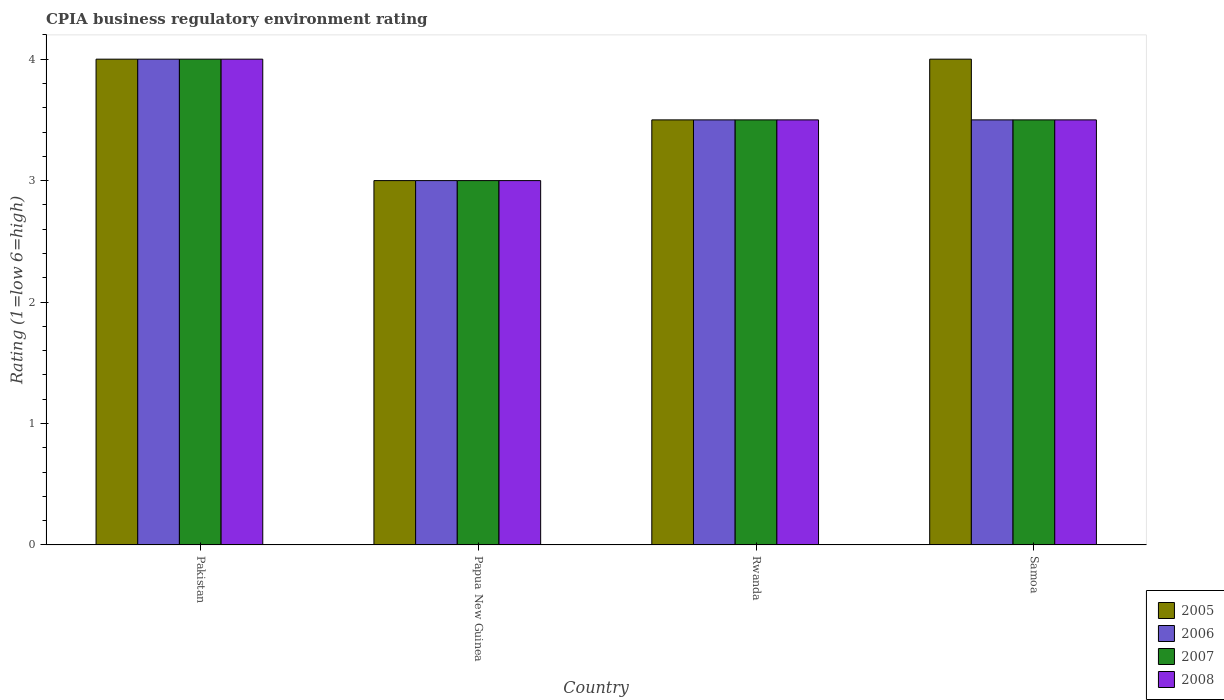Are the number of bars per tick equal to the number of legend labels?
Offer a terse response. Yes. How many bars are there on the 1st tick from the left?
Your answer should be very brief. 4. What is the label of the 4th group of bars from the left?
Provide a short and direct response. Samoa. What is the CPIA rating in 2005 in Papua New Guinea?
Provide a short and direct response. 3. In which country was the CPIA rating in 2007 maximum?
Offer a terse response. Pakistan. In which country was the CPIA rating in 2006 minimum?
Your response must be concise. Papua New Guinea. What is the difference between the CPIA rating in 2008 in Rwanda and the CPIA rating in 2007 in Papua New Guinea?
Your response must be concise. 0.5. In how many countries, is the CPIA rating in 2008 greater than 3?
Ensure brevity in your answer.  3. What is the ratio of the CPIA rating in 2006 in Pakistan to that in Samoa?
Your answer should be compact. 1.14. Is the CPIA rating in 2008 in Papua New Guinea less than that in Samoa?
Ensure brevity in your answer.  Yes. Is the difference between the CPIA rating in 2008 in Papua New Guinea and Samoa greater than the difference between the CPIA rating in 2005 in Papua New Guinea and Samoa?
Make the answer very short. Yes. What is the difference between the highest and the second highest CPIA rating in 2005?
Give a very brief answer. -0.5. Is it the case that in every country, the sum of the CPIA rating in 2006 and CPIA rating in 2007 is greater than the sum of CPIA rating in 2005 and CPIA rating in 2008?
Offer a very short reply. No. What does the 1st bar from the left in Rwanda represents?
Your answer should be compact. 2005. How many bars are there?
Ensure brevity in your answer.  16. Are all the bars in the graph horizontal?
Ensure brevity in your answer.  No. How many countries are there in the graph?
Offer a very short reply. 4. Are the values on the major ticks of Y-axis written in scientific E-notation?
Keep it short and to the point. No. Does the graph contain any zero values?
Provide a succinct answer. No. Does the graph contain grids?
Ensure brevity in your answer.  No. Where does the legend appear in the graph?
Provide a succinct answer. Bottom right. How are the legend labels stacked?
Offer a very short reply. Vertical. What is the title of the graph?
Ensure brevity in your answer.  CPIA business regulatory environment rating. What is the label or title of the X-axis?
Make the answer very short. Country. What is the label or title of the Y-axis?
Ensure brevity in your answer.  Rating (1=low 6=high). What is the Rating (1=low 6=high) in 2008 in Pakistan?
Offer a terse response. 4. What is the Rating (1=low 6=high) of 2006 in Papua New Guinea?
Make the answer very short. 3. What is the Rating (1=low 6=high) of 2005 in Rwanda?
Your response must be concise. 3.5. What is the Rating (1=low 6=high) of 2006 in Rwanda?
Your answer should be very brief. 3.5. What is the Rating (1=low 6=high) of 2007 in Rwanda?
Make the answer very short. 3.5. What is the Rating (1=low 6=high) of 2006 in Samoa?
Your response must be concise. 3.5. What is the Rating (1=low 6=high) in 2008 in Samoa?
Offer a terse response. 3.5. Across all countries, what is the maximum Rating (1=low 6=high) in 2005?
Ensure brevity in your answer.  4. Across all countries, what is the maximum Rating (1=low 6=high) of 2007?
Provide a succinct answer. 4. Across all countries, what is the minimum Rating (1=low 6=high) of 2005?
Give a very brief answer. 3. Across all countries, what is the minimum Rating (1=low 6=high) in 2006?
Provide a short and direct response. 3. What is the total Rating (1=low 6=high) in 2006 in the graph?
Offer a very short reply. 14. What is the difference between the Rating (1=low 6=high) of 2008 in Pakistan and that in Papua New Guinea?
Keep it short and to the point. 1. What is the difference between the Rating (1=low 6=high) of 2005 in Pakistan and that in Rwanda?
Offer a terse response. 0.5. What is the difference between the Rating (1=low 6=high) of 2006 in Pakistan and that in Rwanda?
Keep it short and to the point. 0.5. What is the difference between the Rating (1=low 6=high) of 2005 in Pakistan and that in Samoa?
Your response must be concise. 0. What is the difference between the Rating (1=low 6=high) of 2006 in Pakistan and that in Samoa?
Make the answer very short. 0.5. What is the difference between the Rating (1=low 6=high) of 2007 in Pakistan and that in Samoa?
Give a very brief answer. 0.5. What is the difference between the Rating (1=low 6=high) in 2008 in Papua New Guinea and that in Rwanda?
Offer a very short reply. -0.5. What is the difference between the Rating (1=low 6=high) in 2005 in Papua New Guinea and that in Samoa?
Give a very brief answer. -1. What is the difference between the Rating (1=low 6=high) in 2006 in Papua New Guinea and that in Samoa?
Give a very brief answer. -0.5. What is the difference between the Rating (1=low 6=high) in 2008 in Papua New Guinea and that in Samoa?
Keep it short and to the point. -0.5. What is the difference between the Rating (1=low 6=high) of 2005 in Rwanda and that in Samoa?
Your response must be concise. -0.5. What is the difference between the Rating (1=low 6=high) in 2007 in Rwanda and that in Samoa?
Offer a very short reply. 0. What is the difference between the Rating (1=low 6=high) in 2005 in Pakistan and the Rating (1=low 6=high) in 2006 in Papua New Guinea?
Make the answer very short. 1. What is the difference between the Rating (1=low 6=high) in 2006 in Pakistan and the Rating (1=low 6=high) in 2008 in Papua New Guinea?
Make the answer very short. 1. What is the difference between the Rating (1=low 6=high) in 2005 in Pakistan and the Rating (1=low 6=high) in 2007 in Rwanda?
Make the answer very short. 0.5. What is the difference between the Rating (1=low 6=high) of 2006 in Pakistan and the Rating (1=low 6=high) of 2007 in Rwanda?
Provide a succinct answer. 0.5. What is the difference between the Rating (1=low 6=high) in 2006 in Pakistan and the Rating (1=low 6=high) in 2008 in Rwanda?
Provide a short and direct response. 0.5. What is the difference between the Rating (1=low 6=high) of 2007 in Pakistan and the Rating (1=low 6=high) of 2008 in Rwanda?
Keep it short and to the point. 0.5. What is the difference between the Rating (1=low 6=high) in 2005 in Pakistan and the Rating (1=low 6=high) in 2006 in Samoa?
Provide a short and direct response. 0.5. What is the difference between the Rating (1=low 6=high) of 2007 in Pakistan and the Rating (1=low 6=high) of 2008 in Samoa?
Make the answer very short. 0.5. What is the difference between the Rating (1=low 6=high) of 2005 in Papua New Guinea and the Rating (1=low 6=high) of 2006 in Rwanda?
Your response must be concise. -0.5. What is the difference between the Rating (1=low 6=high) in 2005 in Papua New Guinea and the Rating (1=low 6=high) in 2007 in Rwanda?
Your answer should be very brief. -0.5. What is the difference between the Rating (1=low 6=high) of 2005 in Papua New Guinea and the Rating (1=low 6=high) of 2008 in Rwanda?
Provide a succinct answer. -0.5. What is the difference between the Rating (1=low 6=high) of 2006 in Papua New Guinea and the Rating (1=low 6=high) of 2007 in Rwanda?
Provide a short and direct response. -0.5. What is the difference between the Rating (1=low 6=high) in 2005 in Papua New Guinea and the Rating (1=low 6=high) in 2006 in Samoa?
Offer a terse response. -0.5. What is the difference between the Rating (1=low 6=high) of 2005 in Papua New Guinea and the Rating (1=low 6=high) of 2007 in Samoa?
Give a very brief answer. -0.5. What is the difference between the Rating (1=low 6=high) of 2006 in Papua New Guinea and the Rating (1=low 6=high) of 2007 in Samoa?
Your answer should be very brief. -0.5. What is the difference between the Rating (1=low 6=high) in 2006 in Papua New Guinea and the Rating (1=low 6=high) in 2008 in Samoa?
Give a very brief answer. -0.5. What is the difference between the Rating (1=low 6=high) of 2005 in Rwanda and the Rating (1=low 6=high) of 2007 in Samoa?
Ensure brevity in your answer.  0. What is the difference between the Rating (1=low 6=high) in 2006 in Rwanda and the Rating (1=low 6=high) in 2008 in Samoa?
Give a very brief answer. 0. What is the difference between the Rating (1=low 6=high) of 2007 in Rwanda and the Rating (1=low 6=high) of 2008 in Samoa?
Offer a terse response. 0. What is the average Rating (1=low 6=high) of 2005 per country?
Offer a terse response. 3.62. What is the average Rating (1=low 6=high) of 2007 per country?
Make the answer very short. 3.5. What is the difference between the Rating (1=low 6=high) of 2005 and Rating (1=low 6=high) of 2007 in Pakistan?
Give a very brief answer. 0. What is the difference between the Rating (1=low 6=high) in 2005 and Rating (1=low 6=high) in 2008 in Pakistan?
Offer a very short reply. 0. What is the difference between the Rating (1=low 6=high) of 2006 and Rating (1=low 6=high) of 2007 in Pakistan?
Provide a short and direct response. 0. What is the difference between the Rating (1=low 6=high) in 2006 and Rating (1=low 6=high) in 2008 in Pakistan?
Offer a terse response. 0. What is the difference between the Rating (1=low 6=high) in 2007 and Rating (1=low 6=high) in 2008 in Pakistan?
Your response must be concise. 0. What is the difference between the Rating (1=low 6=high) of 2005 and Rating (1=low 6=high) of 2006 in Papua New Guinea?
Make the answer very short. 0. What is the difference between the Rating (1=low 6=high) of 2005 and Rating (1=low 6=high) of 2008 in Papua New Guinea?
Provide a short and direct response. 0. What is the difference between the Rating (1=low 6=high) in 2007 and Rating (1=low 6=high) in 2008 in Papua New Guinea?
Provide a short and direct response. 0. What is the difference between the Rating (1=low 6=high) of 2005 and Rating (1=low 6=high) of 2007 in Rwanda?
Keep it short and to the point. 0. What is the difference between the Rating (1=low 6=high) in 2005 and Rating (1=low 6=high) in 2008 in Rwanda?
Provide a succinct answer. 0. What is the difference between the Rating (1=low 6=high) in 2006 and Rating (1=low 6=high) in 2007 in Rwanda?
Provide a short and direct response. 0. What is the difference between the Rating (1=low 6=high) in 2007 and Rating (1=low 6=high) in 2008 in Rwanda?
Give a very brief answer. 0. What is the difference between the Rating (1=low 6=high) in 2005 and Rating (1=low 6=high) in 2007 in Samoa?
Offer a very short reply. 0.5. What is the difference between the Rating (1=low 6=high) of 2005 and Rating (1=low 6=high) of 2008 in Samoa?
Give a very brief answer. 0.5. What is the difference between the Rating (1=low 6=high) in 2006 and Rating (1=low 6=high) in 2008 in Samoa?
Your answer should be very brief. 0. What is the ratio of the Rating (1=low 6=high) in 2006 in Pakistan to that in Papua New Guinea?
Your answer should be compact. 1.33. What is the ratio of the Rating (1=low 6=high) in 2008 in Pakistan to that in Papua New Guinea?
Provide a short and direct response. 1.33. What is the ratio of the Rating (1=low 6=high) in 2006 in Pakistan to that in Rwanda?
Your answer should be very brief. 1.14. What is the ratio of the Rating (1=low 6=high) of 2007 in Pakistan to that in Rwanda?
Offer a terse response. 1.14. What is the ratio of the Rating (1=low 6=high) in 2005 in Pakistan to that in Samoa?
Offer a terse response. 1. What is the ratio of the Rating (1=low 6=high) of 2006 in Pakistan to that in Samoa?
Offer a terse response. 1.14. What is the ratio of the Rating (1=low 6=high) in 2007 in Pakistan to that in Samoa?
Your answer should be very brief. 1.14. What is the ratio of the Rating (1=low 6=high) of 2006 in Papua New Guinea to that in Rwanda?
Your response must be concise. 0.86. What is the ratio of the Rating (1=low 6=high) of 2008 in Papua New Guinea to that in Rwanda?
Offer a very short reply. 0.86. What is the ratio of the Rating (1=low 6=high) in 2006 in Papua New Guinea to that in Samoa?
Keep it short and to the point. 0.86. What is the ratio of the Rating (1=low 6=high) of 2007 in Papua New Guinea to that in Samoa?
Offer a terse response. 0.86. What is the ratio of the Rating (1=low 6=high) of 2008 in Papua New Guinea to that in Samoa?
Your response must be concise. 0.86. What is the ratio of the Rating (1=low 6=high) of 2005 in Rwanda to that in Samoa?
Ensure brevity in your answer.  0.88. What is the ratio of the Rating (1=low 6=high) of 2006 in Rwanda to that in Samoa?
Keep it short and to the point. 1. What is the ratio of the Rating (1=low 6=high) of 2008 in Rwanda to that in Samoa?
Make the answer very short. 1. What is the difference between the highest and the second highest Rating (1=low 6=high) of 2005?
Provide a succinct answer. 0. What is the difference between the highest and the second highest Rating (1=low 6=high) of 2006?
Keep it short and to the point. 0.5. What is the difference between the highest and the second highest Rating (1=low 6=high) of 2007?
Provide a short and direct response. 0.5. What is the difference between the highest and the second highest Rating (1=low 6=high) in 2008?
Give a very brief answer. 0.5. What is the difference between the highest and the lowest Rating (1=low 6=high) in 2005?
Make the answer very short. 1. 